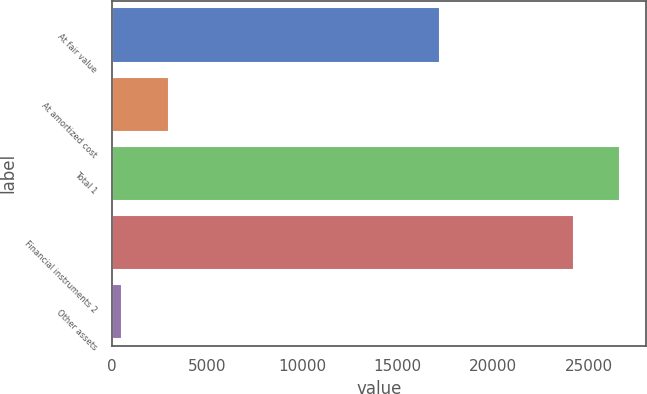Convert chart. <chart><loc_0><loc_0><loc_500><loc_500><bar_chart><fcel>At fair value<fcel>At amortized cost<fcel>Total 1<fcel>Financial instruments 2<fcel>Other assets<nl><fcel>17202<fcel>2992.6<fcel>26670.6<fcel>24246<fcel>568<nl></chart> 